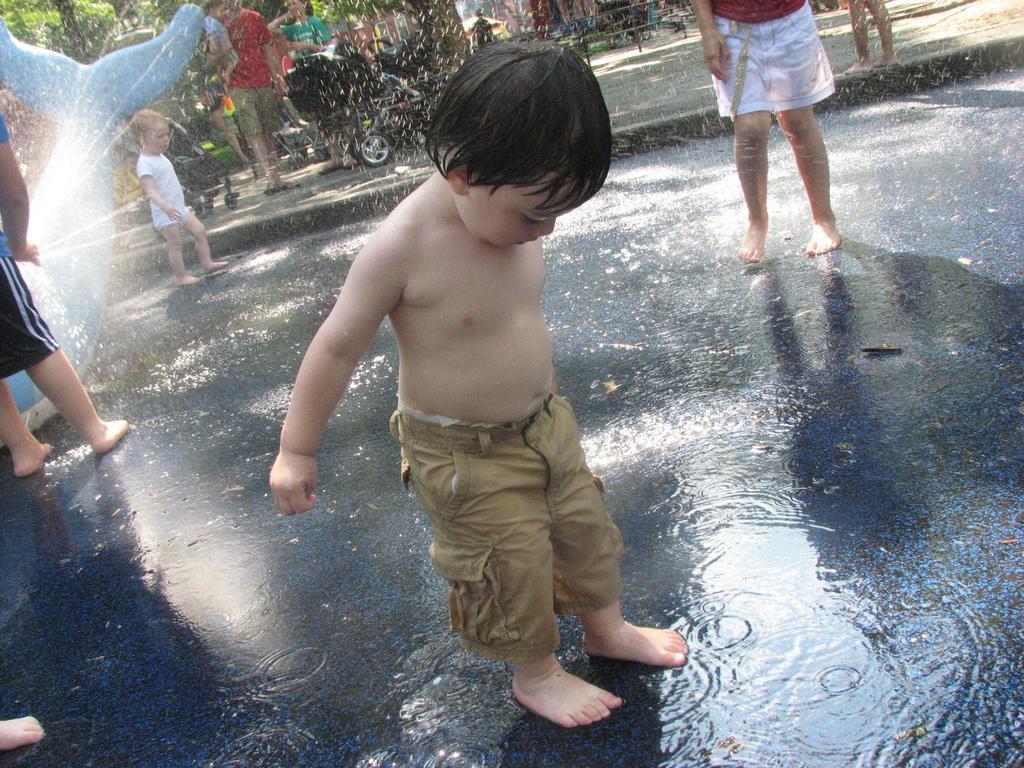Describe this image in one or two sentences. In this image we can see a boy in the foreground who is standing in the water. Behind the boy we can see few more persons, vehicle and trees. On the left side, we can see a person, water and a toy. 